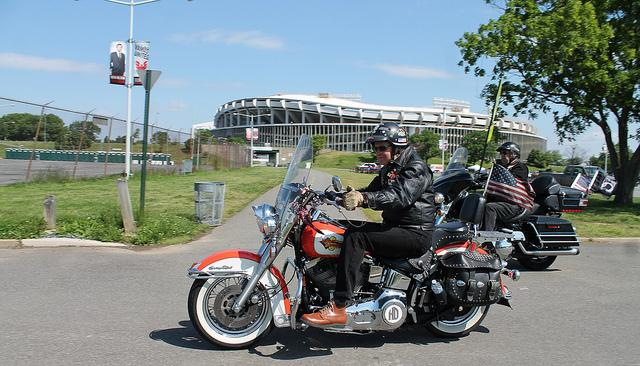What color is the rubber surrounding the outer rim of the tire on these bikes? black 